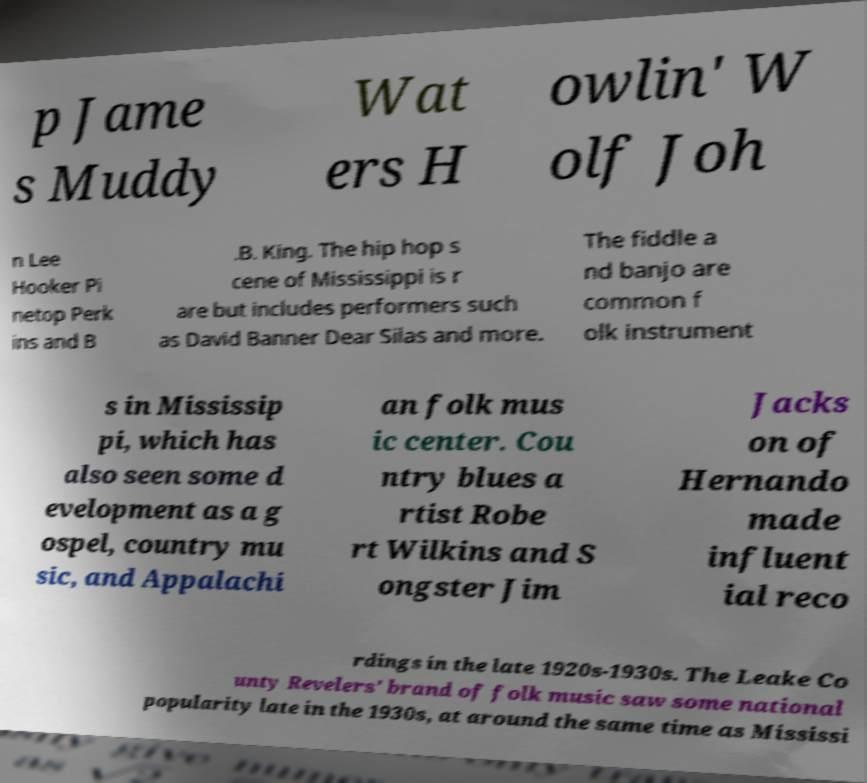For documentation purposes, I need the text within this image transcribed. Could you provide that? p Jame s Muddy Wat ers H owlin' W olf Joh n Lee Hooker Pi netop Perk ins and B .B. King. The hip hop s cene of Mississippi is r are but includes performers such as David Banner Dear Silas and more. The fiddle a nd banjo are common f olk instrument s in Mississip pi, which has also seen some d evelopment as a g ospel, country mu sic, and Appalachi an folk mus ic center. Cou ntry blues a rtist Robe rt Wilkins and S ongster Jim Jacks on of Hernando made influent ial reco rdings in the late 1920s-1930s. The Leake Co unty Revelers' brand of folk music saw some national popularity late in the 1930s, at around the same time as Mississi 